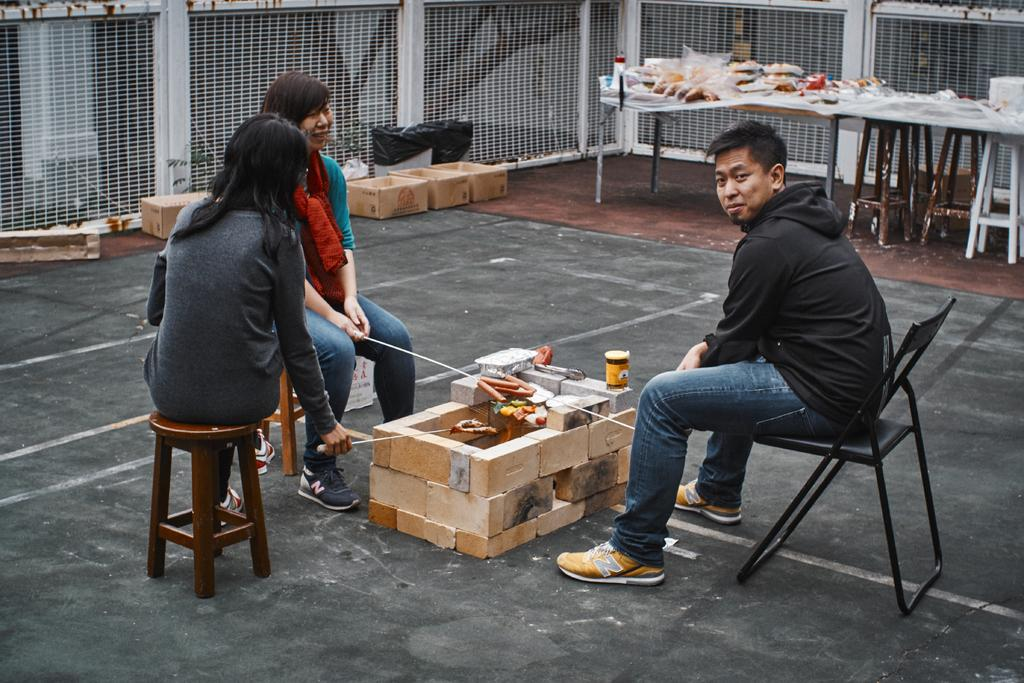How many people are in the image? There are three people in the image. What are the people sitting on? The people are sitting on stools. What is behind the stools? There are bricks behind the stools. What is present in the image besides the people and stools? There is a table in the image. What can be found on the table? There are objects on the table. What type of lace can be seen on the ship in the image? There is no ship or lace present in the image. How does the expansion of the objects on the table affect the image? The objects on the table are not expanding, and there is no indication that expansion is relevant to the image. 